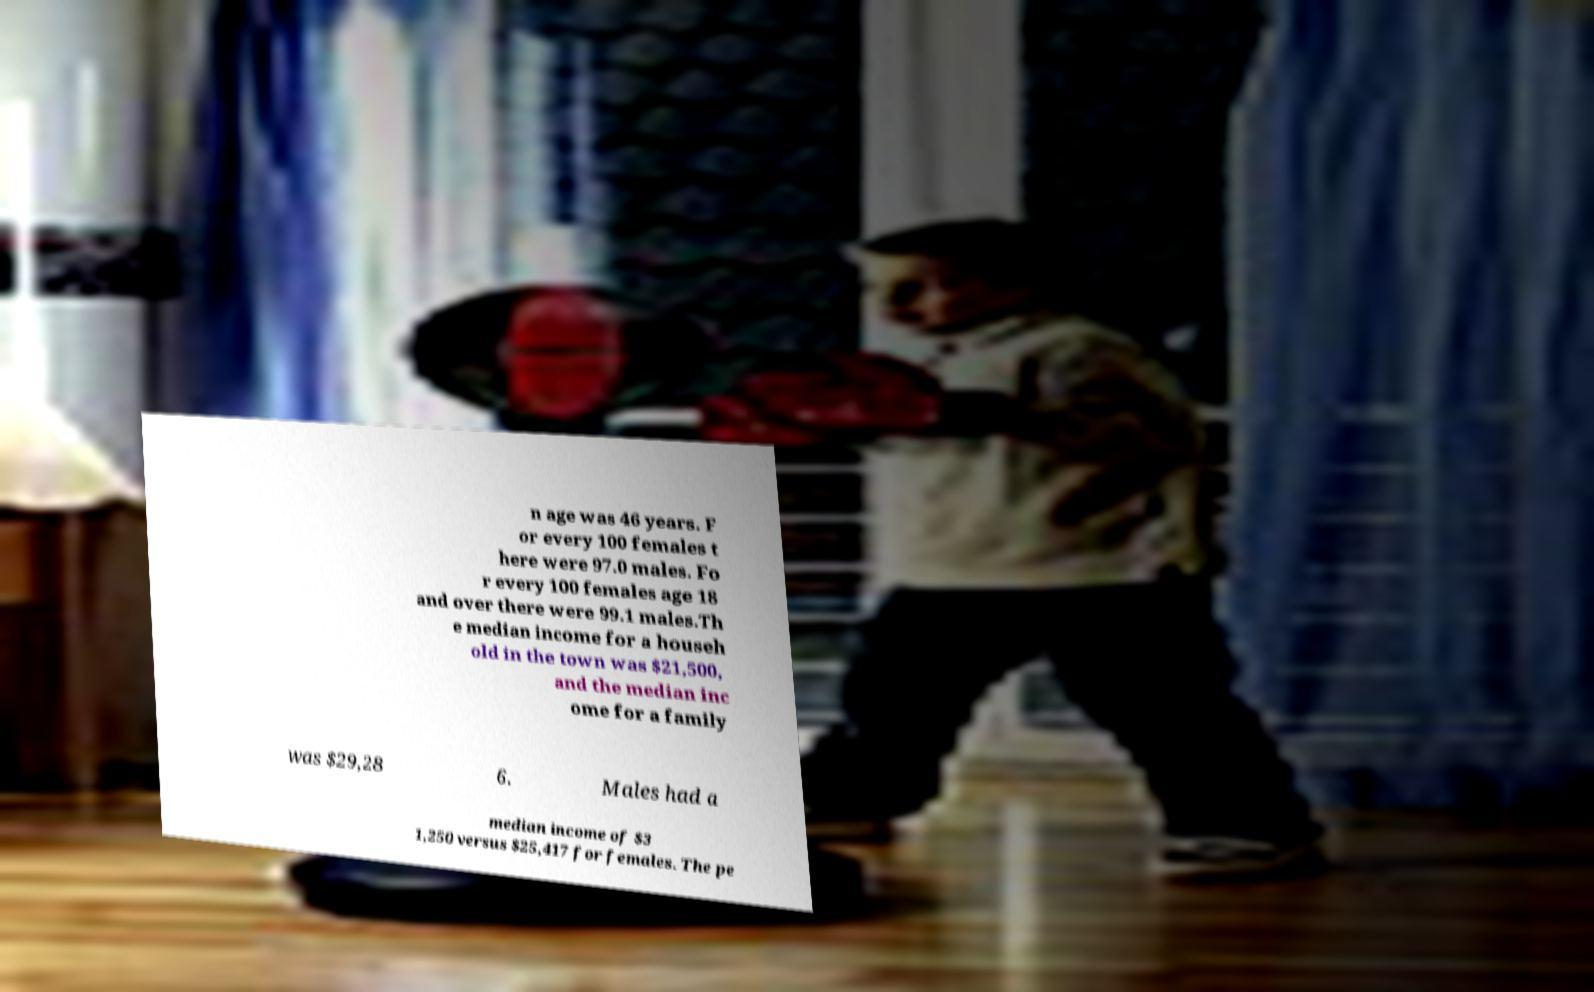I need the written content from this picture converted into text. Can you do that? n age was 46 years. F or every 100 females t here were 97.0 males. Fo r every 100 females age 18 and over there were 99.1 males.Th e median income for a househ old in the town was $21,500, and the median inc ome for a family was $29,28 6. Males had a median income of $3 1,250 versus $25,417 for females. The pe 